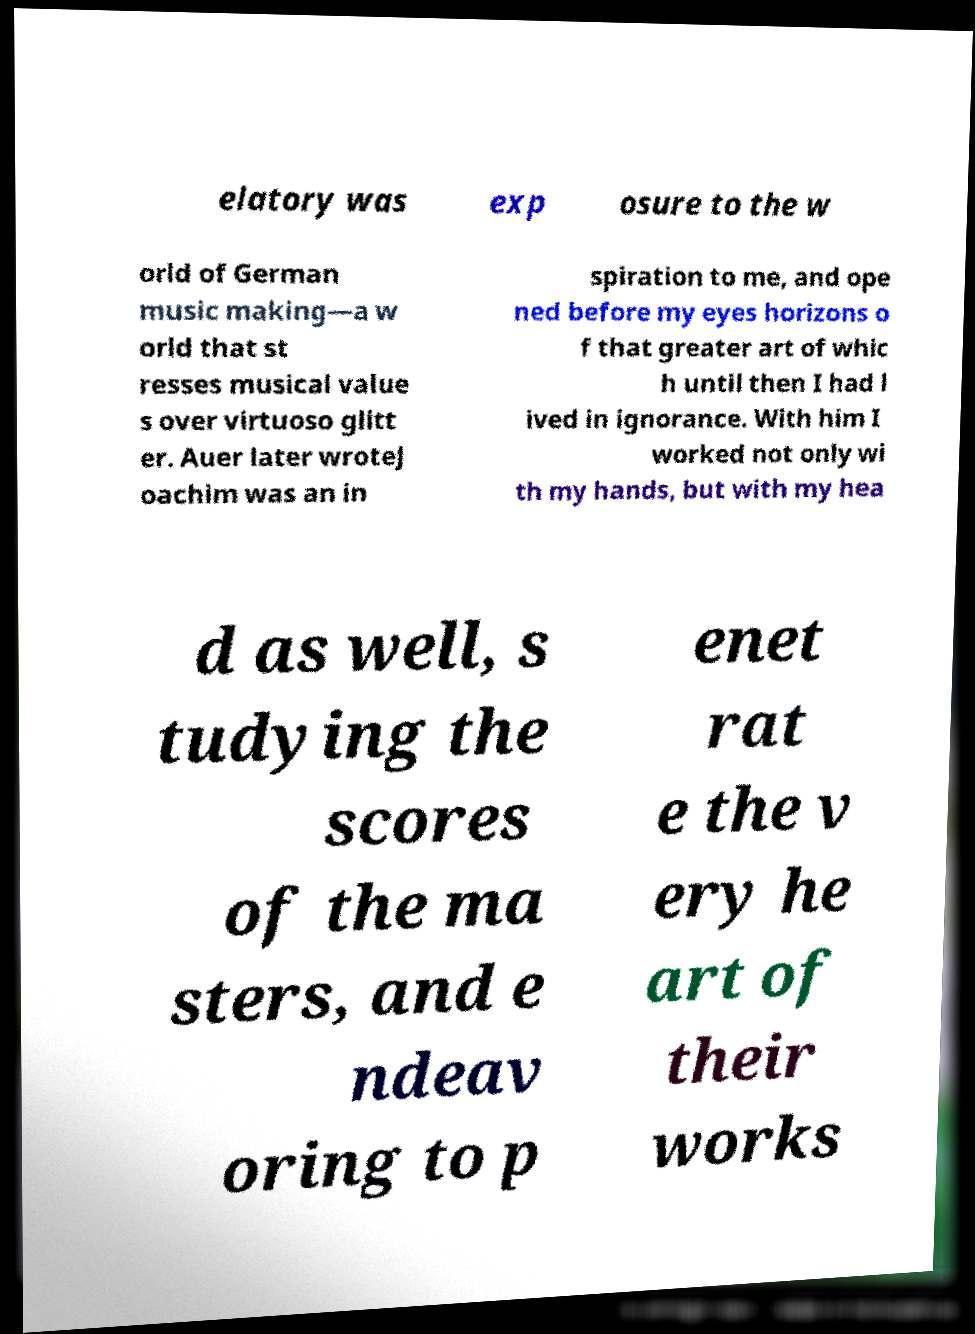Please read and relay the text visible in this image. What does it say? elatory was exp osure to the w orld of German music making—a w orld that st resses musical value s over virtuoso glitt er. Auer later wroteJ oachim was an in spiration to me, and ope ned before my eyes horizons o f that greater art of whic h until then I had l ived in ignorance. With him I worked not only wi th my hands, but with my hea d as well, s tudying the scores of the ma sters, and e ndeav oring to p enet rat e the v ery he art of their works 